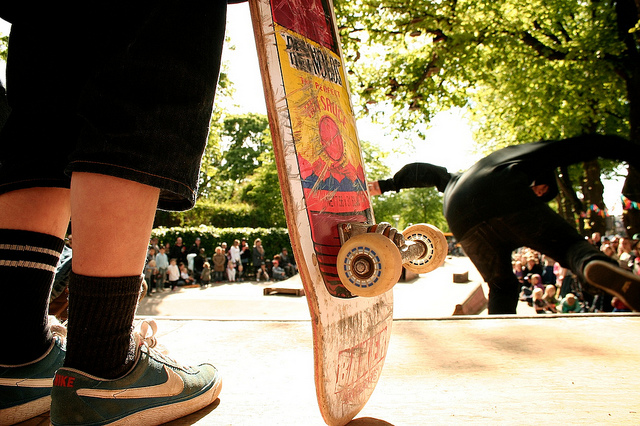Identify the text contained in this image. SPLICE BAKER NIKE 